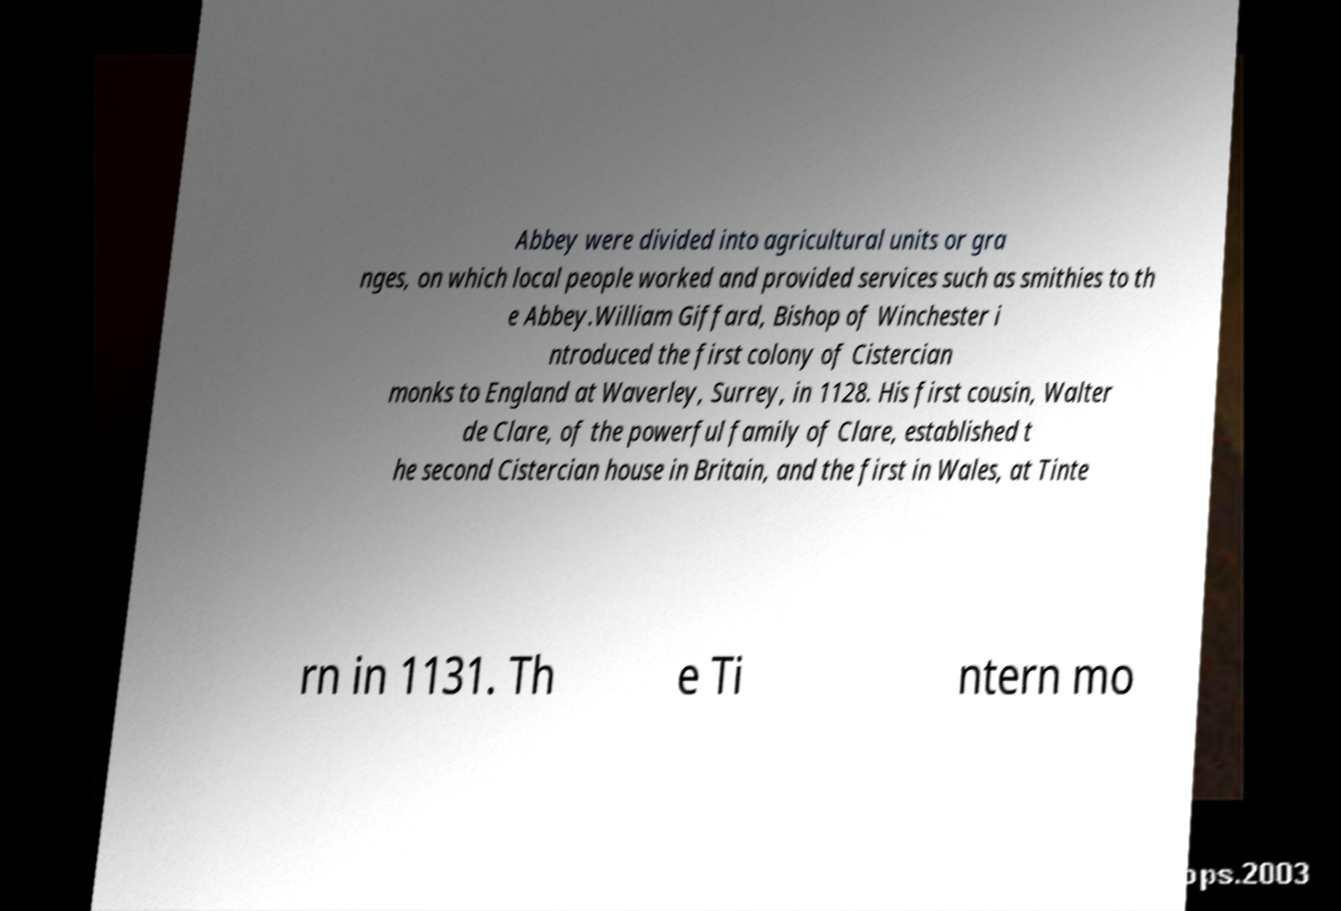There's text embedded in this image that I need extracted. Can you transcribe it verbatim? Abbey were divided into agricultural units or gra nges, on which local people worked and provided services such as smithies to th e Abbey.William Giffard, Bishop of Winchester i ntroduced the first colony of Cistercian monks to England at Waverley, Surrey, in 1128. His first cousin, Walter de Clare, of the powerful family of Clare, established t he second Cistercian house in Britain, and the first in Wales, at Tinte rn in 1131. Th e Ti ntern mo 